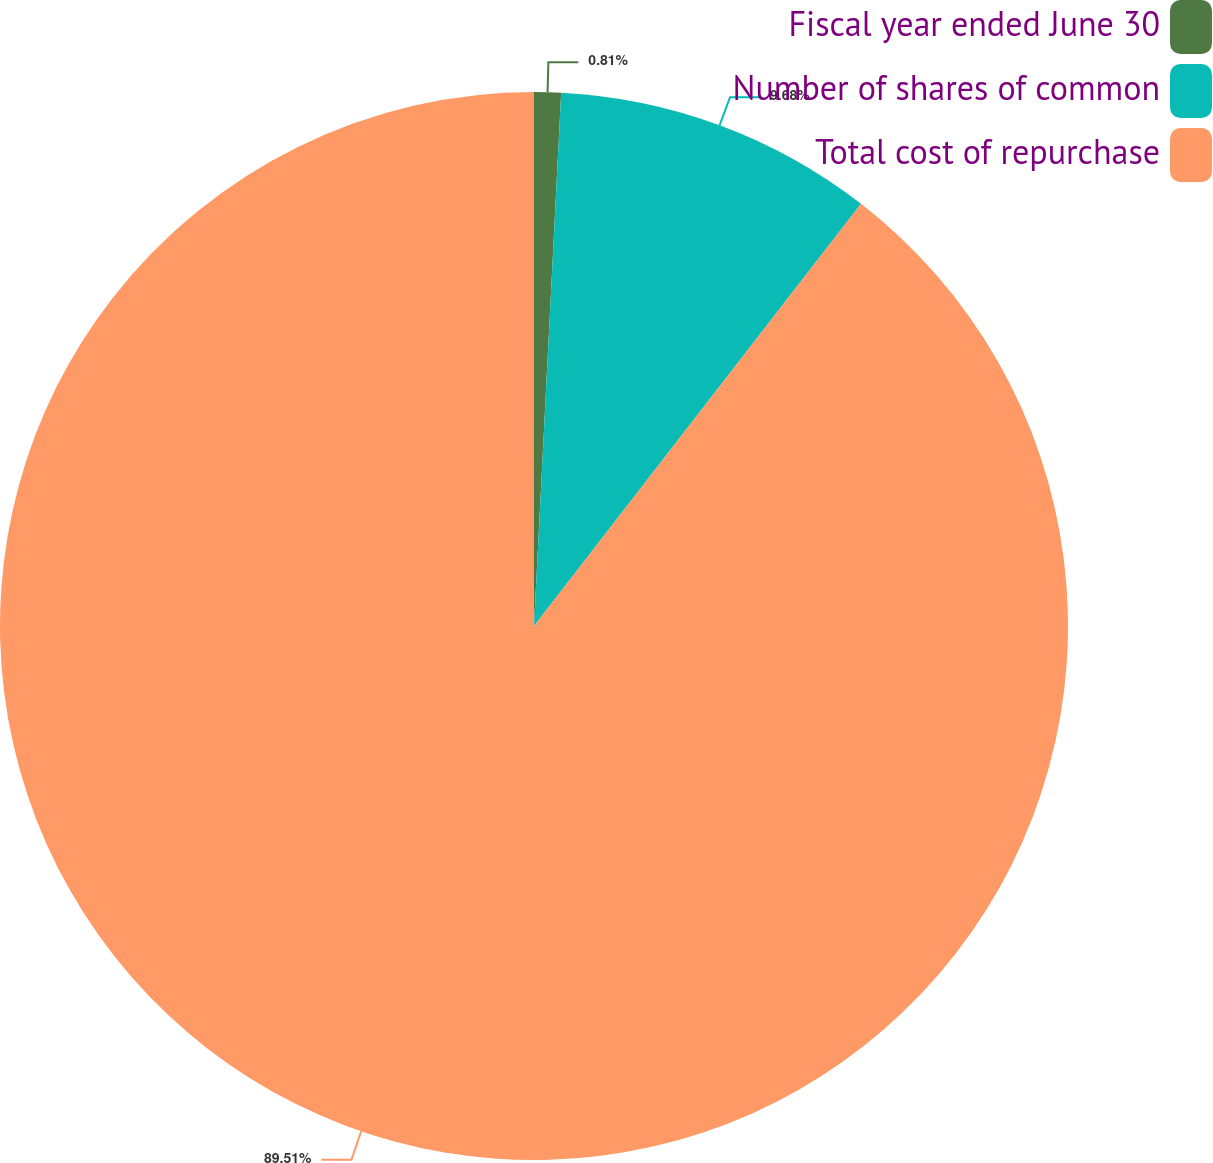Convert chart to OTSL. <chart><loc_0><loc_0><loc_500><loc_500><pie_chart><fcel>Fiscal year ended June 30<fcel>Number of shares of common<fcel>Total cost of repurchase<nl><fcel>0.81%<fcel>9.68%<fcel>89.51%<nl></chart> 